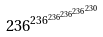Convert formula to latex. <formula><loc_0><loc_0><loc_500><loc_500>2 3 6 ^ { 2 3 6 ^ { 2 3 6 ^ { 2 3 6 ^ { 2 3 6 ^ { 2 3 0 } } } } }</formula> 